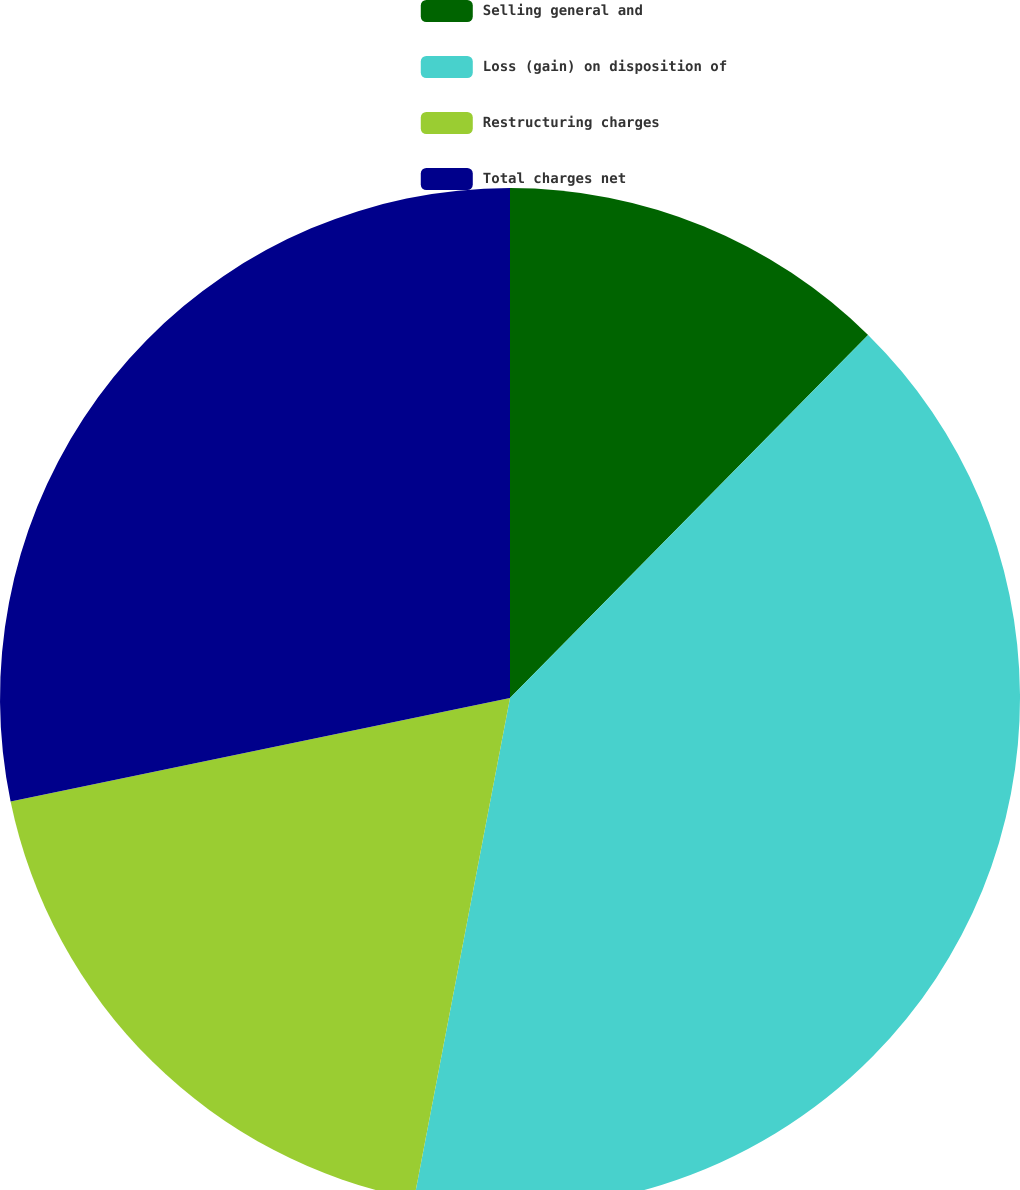Convert chart. <chart><loc_0><loc_0><loc_500><loc_500><pie_chart><fcel>Selling general and<fcel>Loss (gain) on disposition of<fcel>Restructuring charges<fcel>Total charges net<nl><fcel>12.39%<fcel>40.62%<fcel>18.74%<fcel>28.25%<nl></chart> 